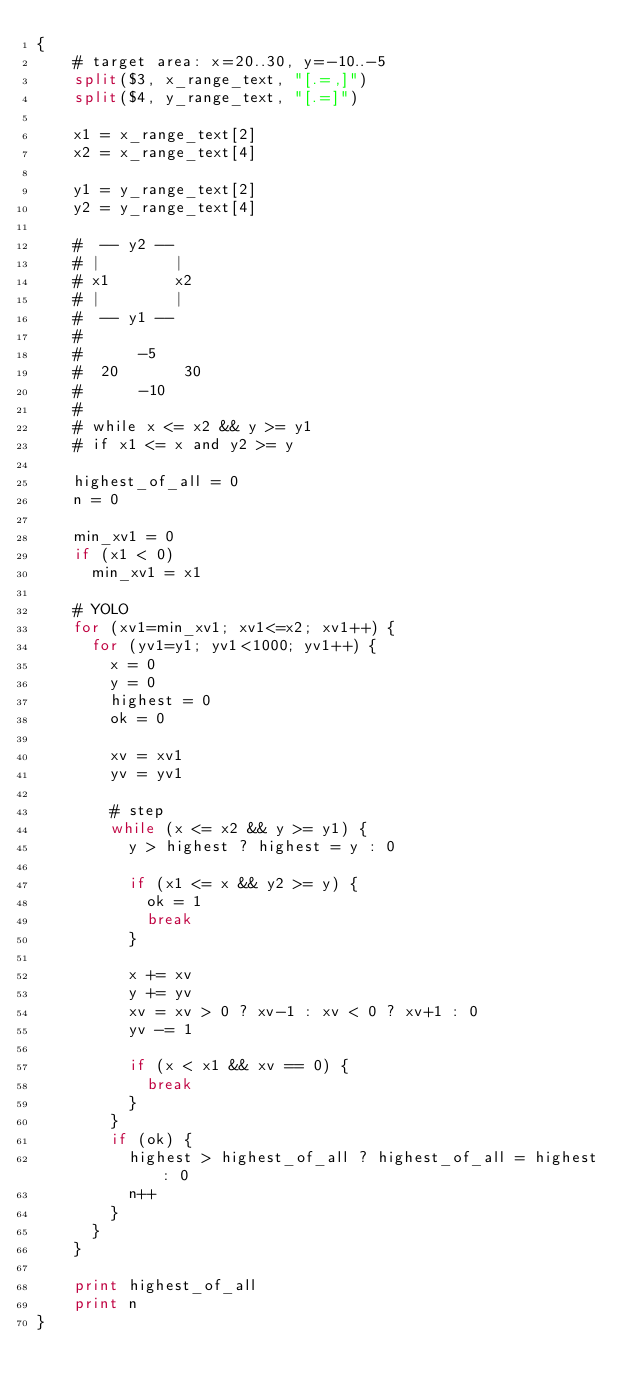<code> <loc_0><loc_0><loc_500><loc_500><_Awk_>{
    # target area: x=20..30, y=-10..-5
    split($3, x_range_text, "[.=,]")
    split($4, y_range_text, "[.=]")

    x1 = x_range_text[2]
    x2 = x_range_text[4]

    y1 = y_range_text[2]
    y2 = y_range_text[4]

    #  -- y2 --
    # |        |
    # x1       x2
    # |        |
    #  -- y1 --
    #
    #      -5
    #  20       30
    #      -10
    #
    # while x <= x2 && y >= y1
    # if x1 <= x and y2 >= y

    highest_of_all = 0
    n = 0

    min_xv1 = 0
    if (x1 < 0)
      min_xv1 = x1

    # YOLO
    for (xv1=min_xv1; xv1<=x2; xv1++) {
      for (yv1=y1; yv1<1000; yv1++) {
        x = 0
        y = 0
        highest = 0
        ok = 0

        xv = xv1
        yv = yv1

        # step
        while (x <= x2 && y >= y1) {
          y > highest ? highest = y : 0

          if (x1 <= x && y2 >= y) {
            ok = 1
            break
          }

          x += xv
          y += yv
          xv = xv > 0 ? xv-1 : xv < 0 ? xv+1 : 0
          yv -= 1

          if (x < x1 && xv == 0) {
            break
          }
        }
        if (ok) {
          highest > highest_of_all ? highest_of_all = highest : 0
          n++
        }
      }
    }

    print highest_of_all
    print n
}
</code> 